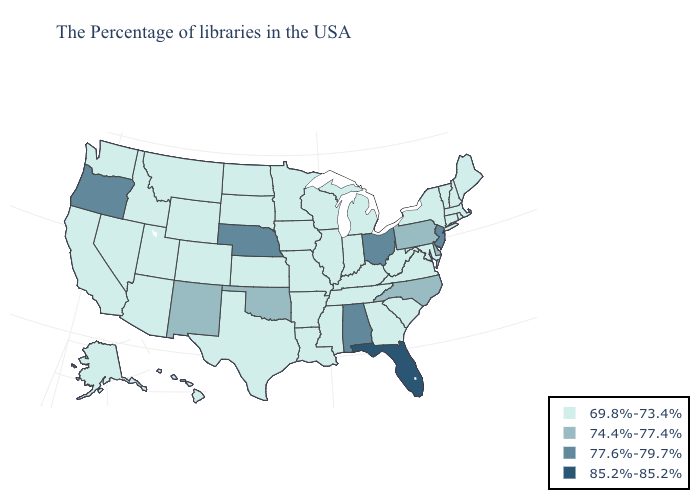Does the map have missing data?
Give a very brief answer. No. What is the value of West Virginia?
Quick response, please. 69.8%-73.4%. Does South Dakota have a lower value than Arkansas?
Give a very brief answer. No. Does Oklahoma have the lowest value in the USA?
Be succinct. No. What is the value of Iowa?
Short answer required. 69.8%-73.4%. Name the states that have a value in the range 85.2%-85.2%?
Short answer required. Florida. What is the value of North Dakota?
Write a very short answer. 69.8%-73.4%. What is the value of North Carolina?
Give a very brief answer. 74.4%-77.4%. What is the value of New Hampshire?
Keep it brief. 69.8%-73.4%. Does the map have missing data?
Concise answer only. No. What is the value of Hawaii?
Give a very brief answer. 69.8%-73.4%. Name the states that have a value in the range 85.2%-85.2%?
Be succinct. Florida. Does the map have missing data?
Answer briefly. No. How many symbols are there in the legend?
Answer briefly. 4. Does Connecticut have the highest value in the Northeast?
Write a very short answer. No. 